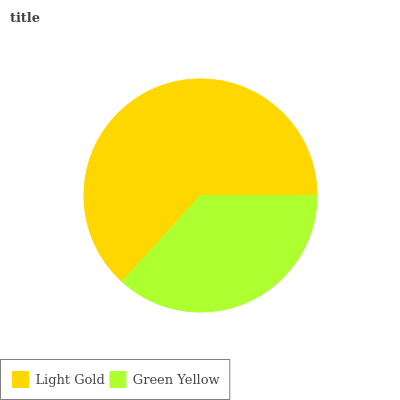Is Green Yellow the minimum?
Answer yes or no. Yes. Is Light Gold the maximum?
Answer yes or no. Yes. Is Green Yellow the maximum?
Answer yes or no. No. Is Light Gold greater than Green Yellow?
Answer yes or no. Yes. Is Green Yellow less than Light Gold?
Answer yes or no. Yes. Is Green Yellow greater than Light Gold?
Answer yes or no. No. Is Light Gold less than Green Yellow?
Answer yes or no. No. Is Light Gold the high median?
Answer yes or no. Yes. Is Green Yellow the low median?
Answer yes or no. Yes. Is Green Yellow the high median?
Answer yes or no. No. Is Light Gold the low median?
Answer yes or no. No. 